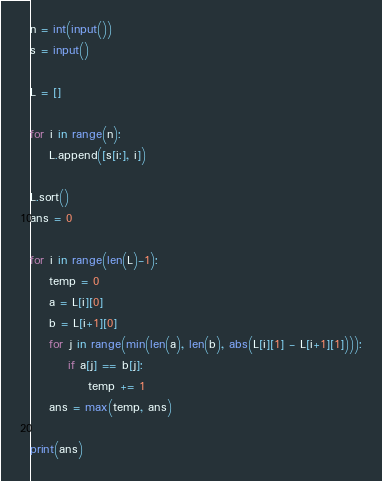Convert code to text. <code><loc_0><loc_0><loc_500><loc_500><_Python_>n = int(input())
s = input()

L = []

for i in range(n):
    L.append([s[i:], i])

L.sort()
ans = 0

for i in range(len(L)-1):
    temp = 0
    a = L[i][0]
    b = L[i+1][0]
    for j in range(min(len(a), len(b), abs(L[i][1] - L[i+1][1]))):
        if a[j] == b[j]:
            temp += 1
    ans = max(temp, ans)

print(ans)

</code> 